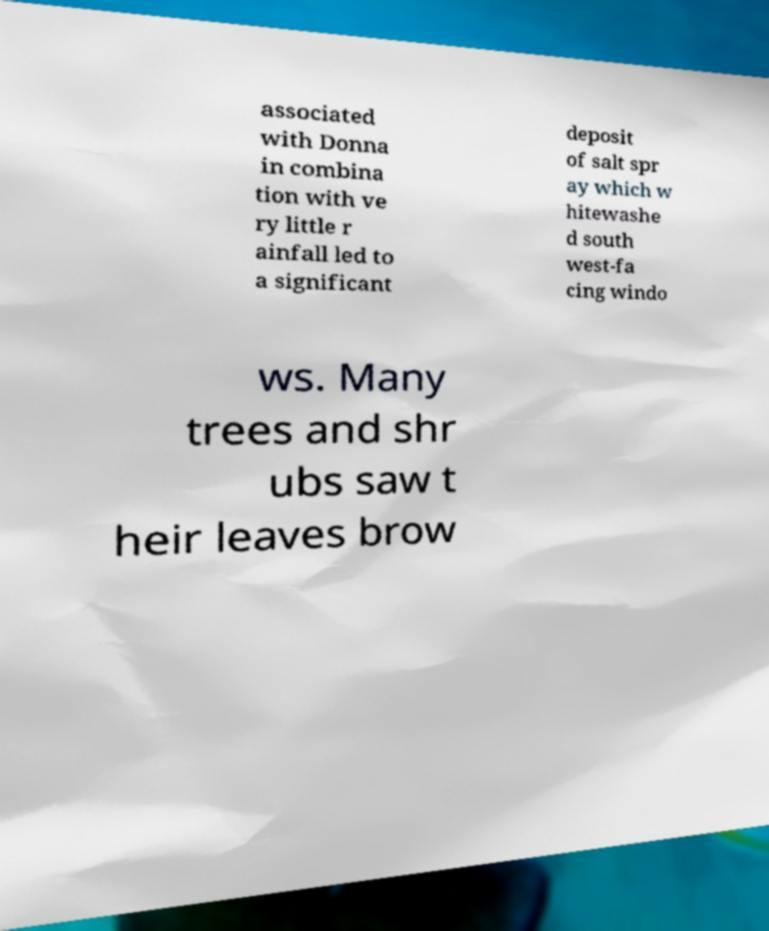Can you read and provide the text displayed in the image?This photo seems to have some interesting text. Can you extract and type it out for me? associated with Donna in combina tion with ve ry little r ainfall led to a significant deposit of salt spr ay which w hitewashe d south west-fa cing windo ws. Many trees and shr ubs saw t heir leaves brow 